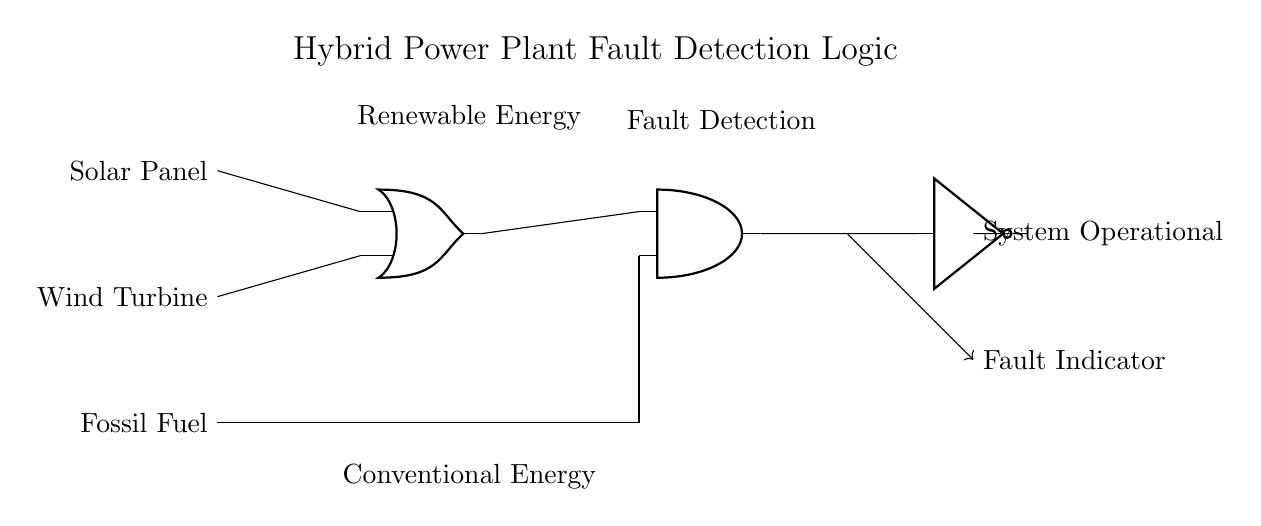What components are present in the circuit? The circuit includes a solar panel, wind turbine, fossil fuel input, an OR gate, an AND gate, and a NOT gate. Each component is visualized in the schematic and serves a specific function in the fault detection logic system.
Answer: solar panel, wind turbine, fossil fuel, OR gate, AND gate, NOT gate What is the function of the OR gate in this circuit? The OR gate combines the outputs from the solar panel and wind turbine, allowing the system to operate if either of the renewable energy sources is producing energy. This indicates the redundancy designed for renewable energy inputs.
Answer: Combining renewable sources What happens when there is a fault detected in the system? When a fault is detected, it causes a signal to go through the AND gate, which then goes to the NOT gate. The NOT gate inverts this signal, indicating that the system is operational when no faults are detected.
Answer: System operational How many inputs does the AND gate have? The AND gate has two inputs: one from the OR gate (for renewable energy) and one from the fossil fuel input, indicating that the system is designed to detect faults regardless of the input source.
Answer: Two inputs What is the output of the NOT gate when there is an operational status? When the system is operational, the NOT gate outputs a signal indicating that there are no faults detected. Since the input to the NOT gate is the signal from the AND gate (which gets activated only when there is an operational state), it effectively signifies that the system is running without faults.
Answer: Fault Indicator What can trigger a fault condition in this logic system? A fault condition can be triggered by either the absence of input from both renewable sources (solar and wind) or any malfunction in the fossil fuel input, which halts the operation of the power plant. The AND gate requires all sources to function to signal operational status.
Answer: Absence of inputs What type of logic circuit is this? This is a hybrid logic circuit that integrates both renewable (solar and wind) and conventional (fossil fuel) energy sources, utilizing OR, AND, and NOT gates for fault detection logic.
Answer: Hybrid logic circuit 